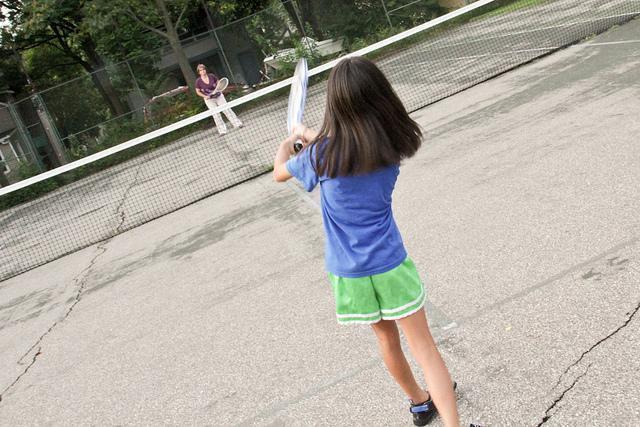Where does the girl want to hit the ball?
Indicate the correct choice and explain in the format: 'Answer: answer
Rationale: rationale.'
Options: Behind net, under net, up, over net. Answer: over net.
Rationale: The girl is swinging her racket upwards, to strike a ball into the air. the rules of tennis call for balls to be hit over the net. 